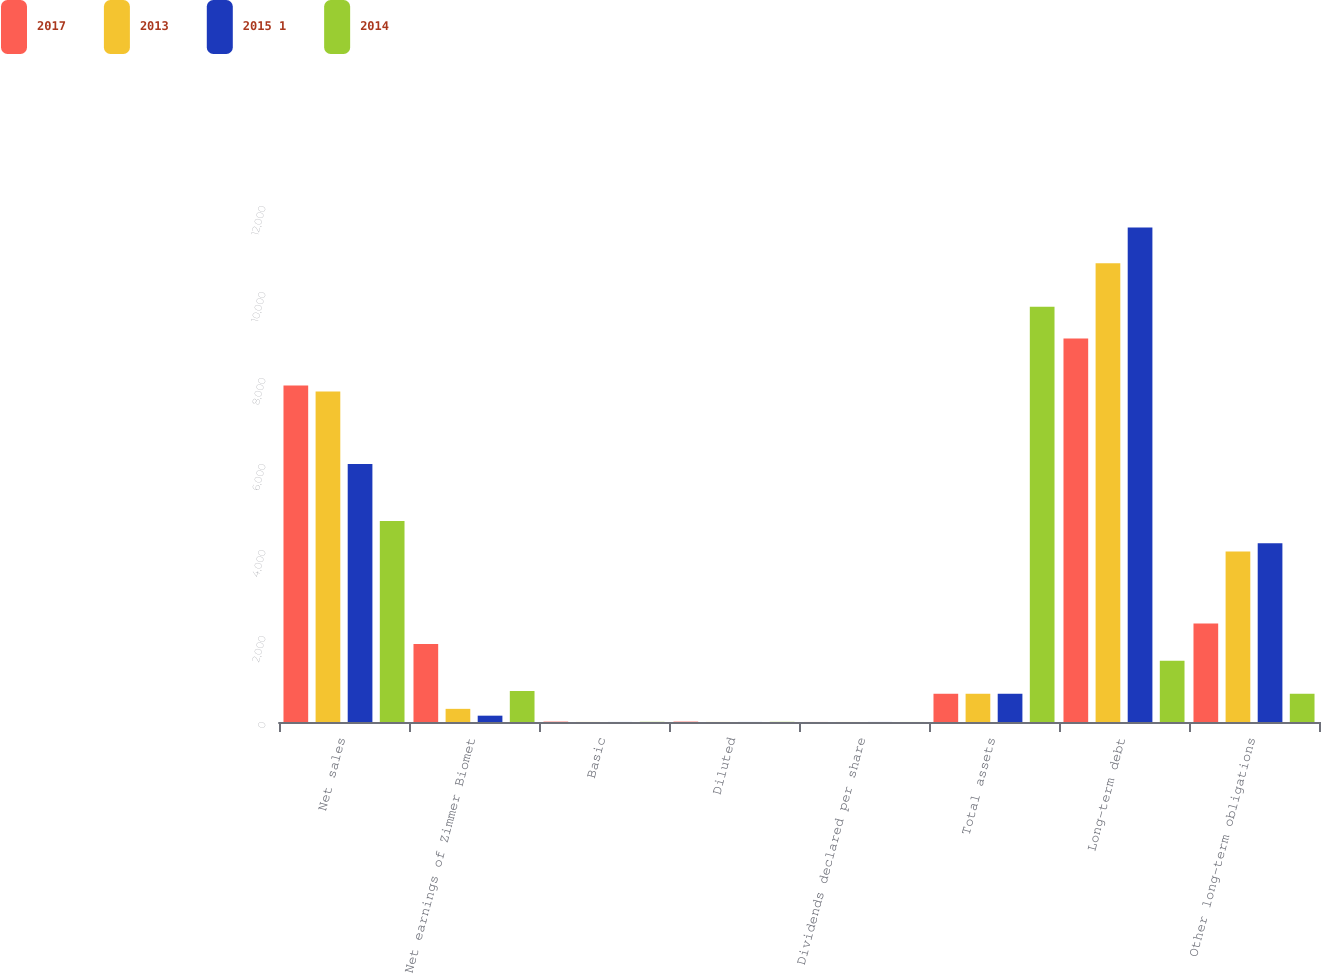Convert chart. <chart><loc_0><loc_0><loc_500><loc_500><stacked_bar_chart><ecel><fcel>Net sales<fcel>Net earnings of Zimmer Biomet<fcel>Basic<fcel>Diluted<fcel>Dividends declared per share<fcel>Total assets<fcel>Long-term debt<fcel>Other long-term obligations<nl><fcel>2017<fcel>7824.1<fcel>1813.8<fcel>8.98<fcel>8.9<fcel>0.96<fcel>656.8<fcel>8917.5<fcel>2291.3<nl><fcel>2013<fcel>7683.9<fcel>305.9<fcel>1.53<fcel>1.51<fcel>0.96<fcel>656.8<fcel>10665.8<fcel>3967.2<nl><fcel>2015 1<fcel>5997.8<fcel>147<fcel>0.78<fcel>0.77<fcel>0.88<fcel>656.8<fcel>11497.4<fcel>4155.9<nl><fcel>2014<fcel>4673.3<fcel>720.3<fcel>4.26<fcel>4.2<fcel>0.88<fcel>9658<fcel>1425.5<fcel>656.8<nl></chart> 